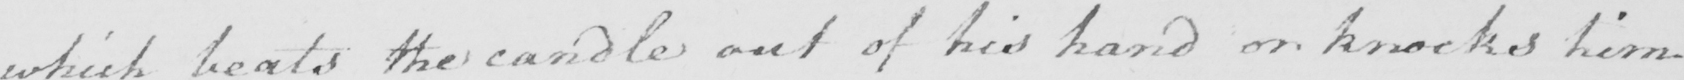Please transcribe the handwritten text in this image. which beats the candle out of his hand or knocks him 